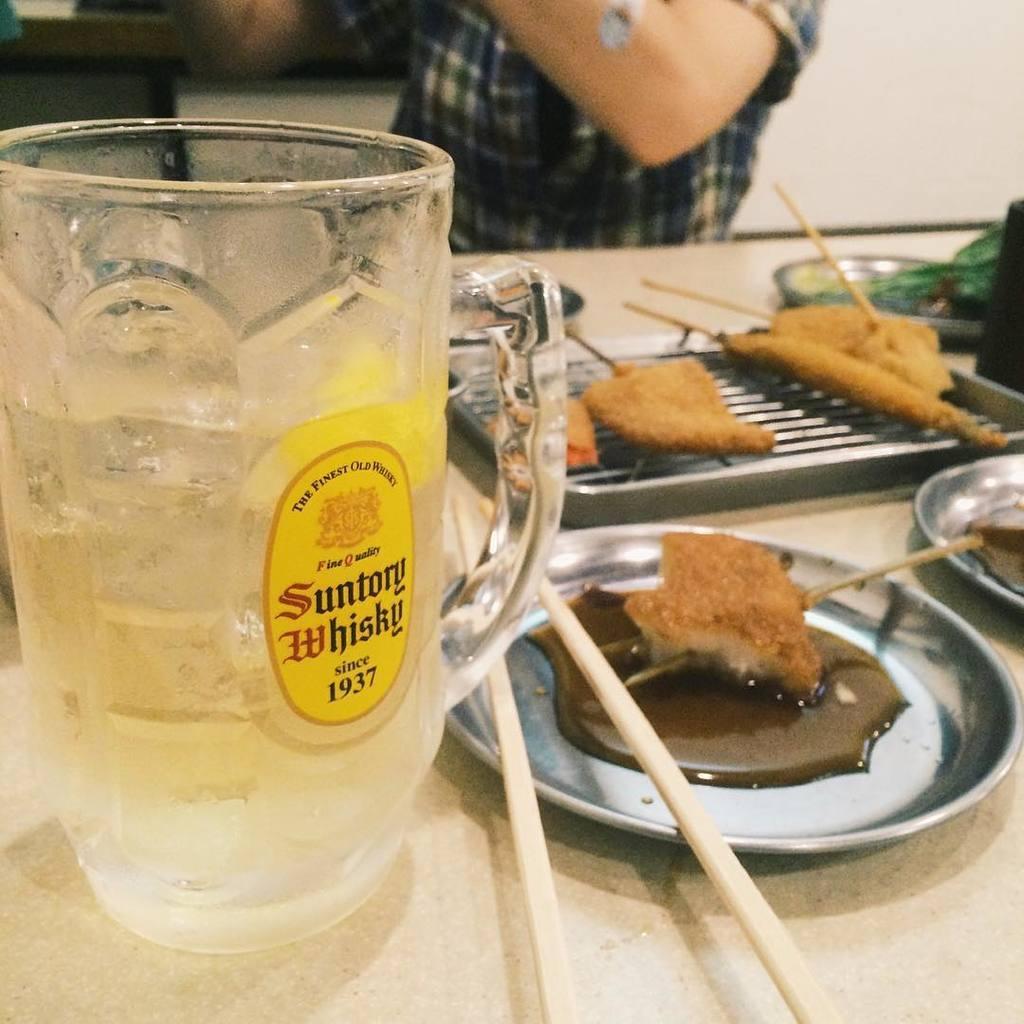How would you summarize this image in a sentence or two? In the center of the image there is a table and we can see a mug, plates, tray, chopsticks and some food placed on the table. In the background we can see a person and a wall. 